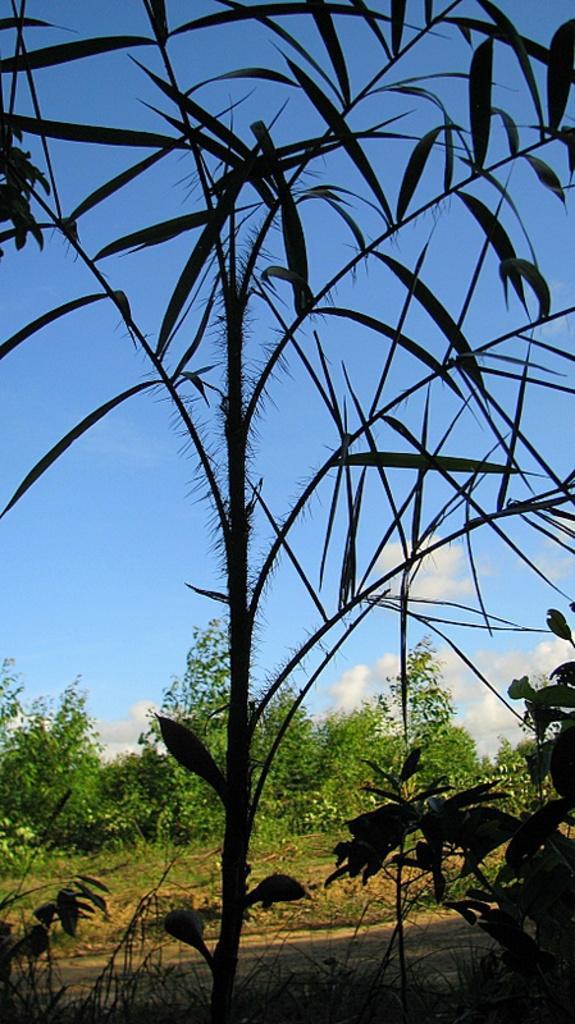Describe this image in one or two sentences. In this image there is a plant in the middle to which there are small leaves. At the top there is the sky. In the background there are trees. On the ground there is sand and grass. 